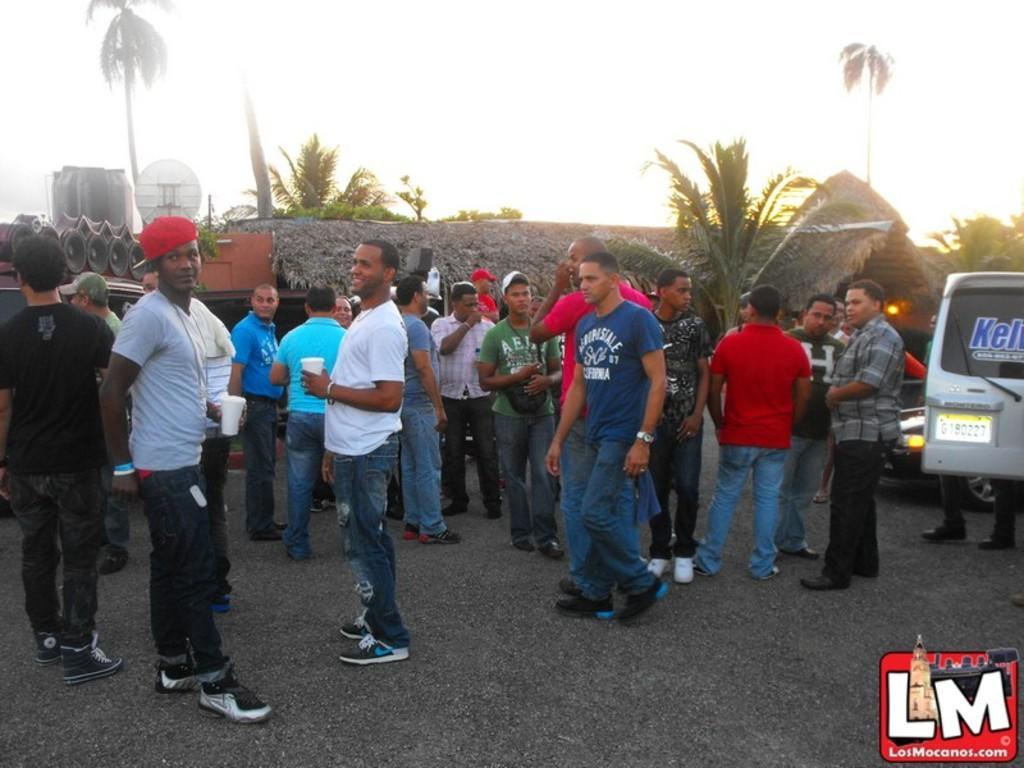Please provide a concise description of this image. In this picture we can see vehicles and people standing on the road and looking somewhere. In the background, we can see a grass hut and a place with trees. At the top we can see a tank and an antenna. The sky is bright. 